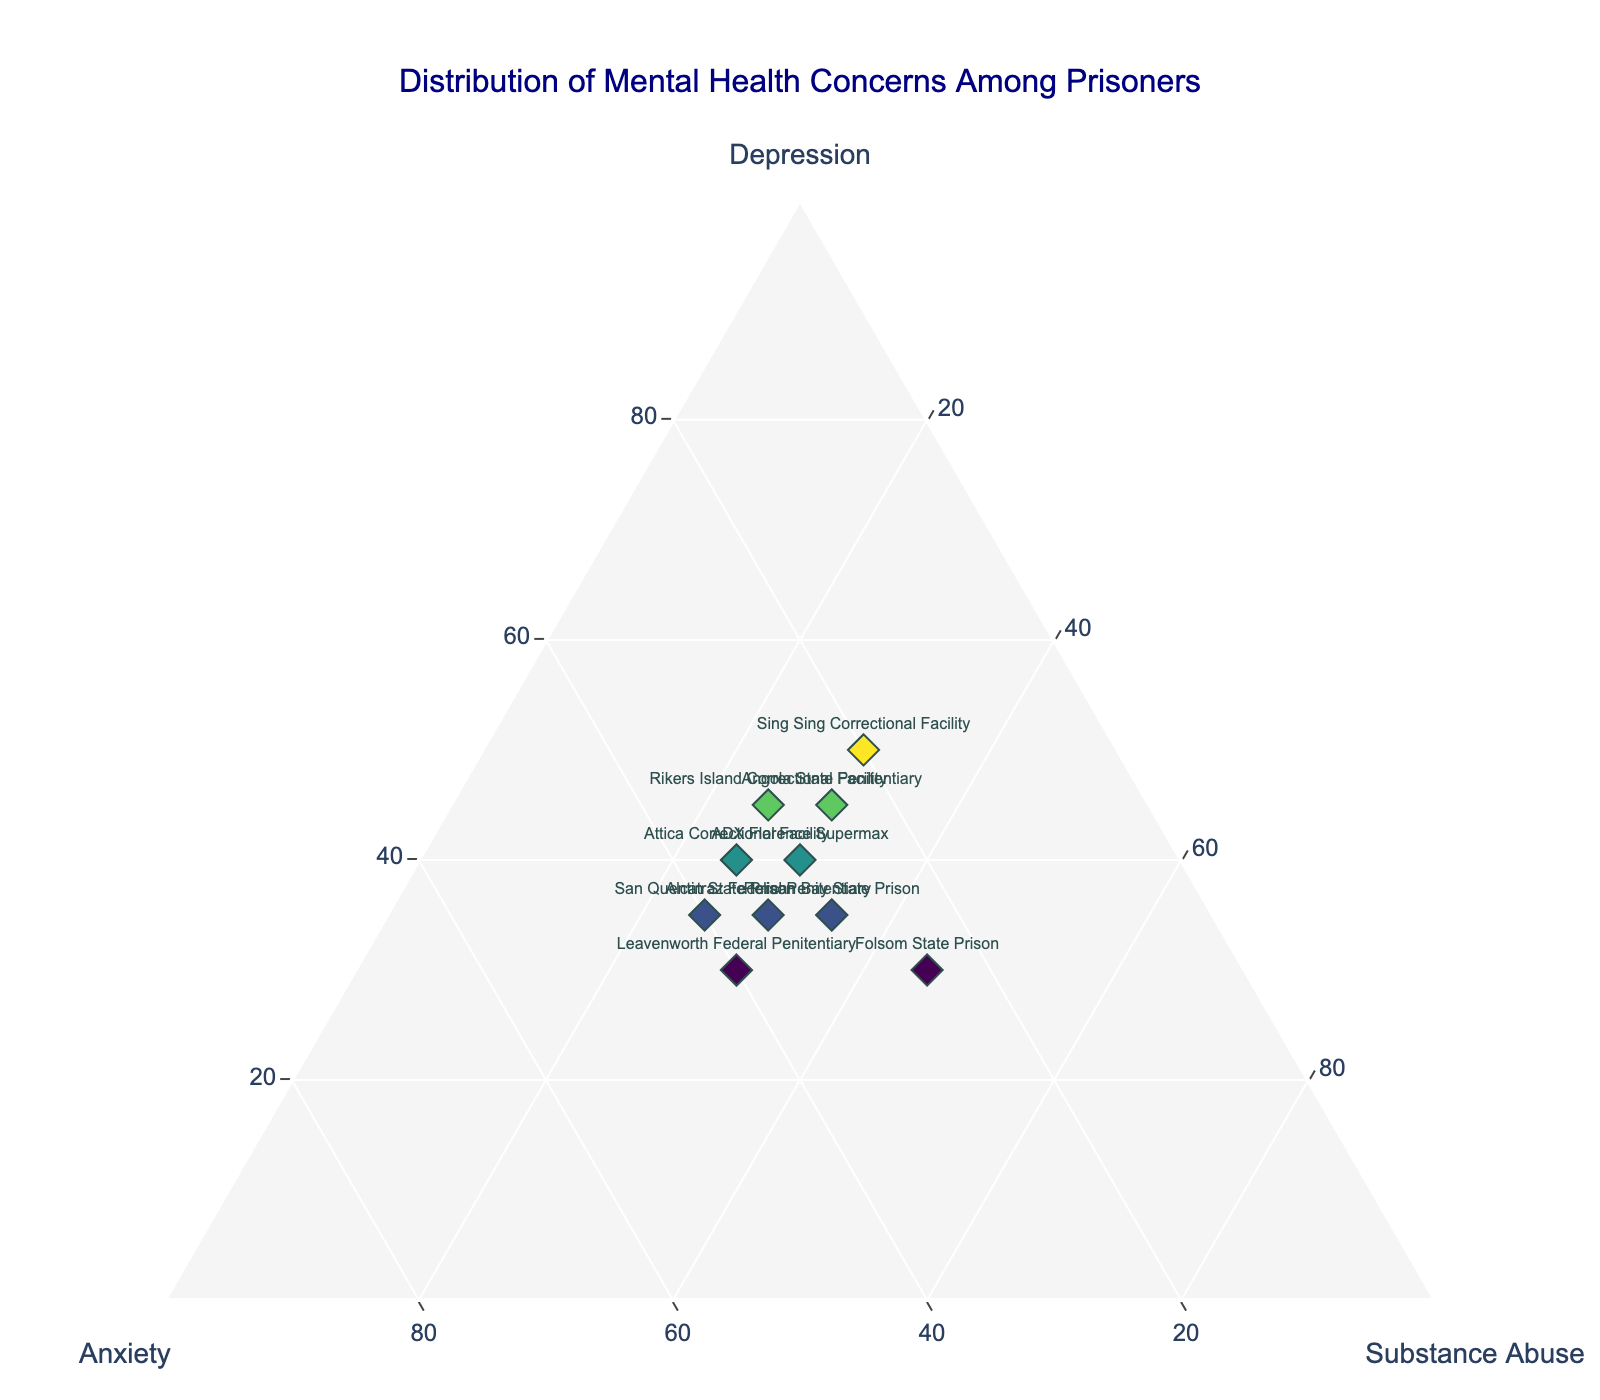What's the title of the figure? The title of the figure is usually positioned at the top center. In this case, it is "Distribution of Mental Health Concerns Among Prisoners".
Answer: Distribution of Mental Health Concerns Among Prisoners What are the three axes labeled on the plot? The three axes of the ternary plot are labeled with "Depression", "Anxiety", and "Substance Abuse".
Answer: Depression, Anxiety, Substance Abuse Which institution has the highest percentage of Substance Abuse concerns? By looking at the plot, Folsom State Prison has the highest percentage of Substance Abuse concerns, marked at 45%.
Answer: Folsom State Prison Which institution shows an equal percentage of Depression and Anxiety? Leavenworth Federal Penitentiary shows an equal percentage of Depression and Anxiety, both at 30%.
Answer: Leavenworth Federal Penitentiary Which institution has the highest percentage of Depression? The institution with the highest percentage of Depression is Sing Sing Correctional Facility with 50%.
Answer: Sing Sing Correctional Facility Compare the density of Depression concerns between Alcatraz Federal Penitentiary and Pelican Bay State Prison. Alcatraz Federal Penitentiary has a Depression percentage of 35 while Pelican Bay State Prison also has a Depression percentage of 35. Thus, the density of Depression concerns is equal.
Answer: Equal Which institution has a higher percentage of Anxiety concerns: San Quentin State Prison or Angola State Penitentiary? San Quentin State Prison has an Anxiety percentage of 40, while Angola State Penitentiary has an Anxiety percentage of 25. Hence, San Quentin State Prison has a higher percentage.
Answer: San Quentin State Prison What is the sum of the percentages of Depression and Substance Abuse concerns for Rikers Island Correctional Facility? The percentage of Depression for Rikers Island Correctional Facility is 45 and Substance Abuse is 25. Summing these gives 45 + 25 = 70.
Answer: 70 